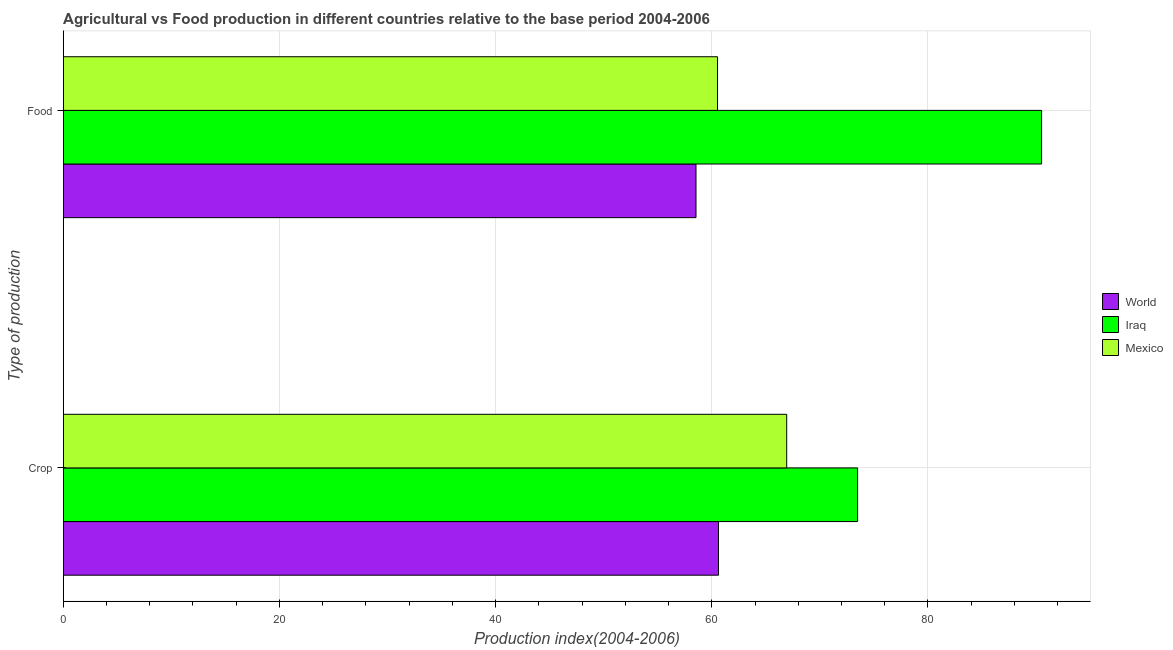How many different coloured bars are there?
Make the answer very short. 3. How many bars are there on the 2nd tick from the top?
Provide a succinct answer. 3. How many bars are there on the 2nd tick from the bottom?
Your answer should be compact. 3. What is the label of the 1st group of bars from the top?
Offer a very short reply. Food. What is the food production index in World?
Your answer should be compact. 58.54. Across all countries, what is the maximum crop production index?
Make the answer very short. 73.49. Across all countries, what is the minimum crop production index?
Ensure brevity in your answer.  60.62. In which country was the crop production index maximum?
Ensure brevity in your answer.  Iraq. In which country was the food production index minimum?
Your answer should be compact. World. What is the total food production index in the graph?
Your response must be concise. 209.58. What is the difference between the crop production index in Mexico and that in World?
Your answer should be compact. 6.31. What is the difference between the crop production index in Iraq and the food production index in World?
Your answer should be compact. 14.95. What is the average food production index per country?
Provide a short and direct response. 69.86. What is the difference between the crop production index and food production index in Mexico?
Offer a terse response. 6.4. In how many countries, is the food production index greater than 12 ?
Your answer should be compact. 3. What is the ratio of the crop production index in Mexico to that in Iraq?
Give a very brief answer. 0.91. Is the food production index in Iraq less than that in Mexico?
Your answer should be very brief. No. In how many countries, is the food production index greater than the average food production index taken over all countries?
Your answer should be compact. 1. What does the 2nd bar from the top in Food represents?
Make the answer very short. Iraq. Are all the bars in the graph horizontal?
Ensure brevity in your answer.  Yes. How many countries are there in the graph?
Your answer should be very brief. 3. What is the difference between two consecutive major ticks on the X-axis?
Ensure brevity in your answer.  20. Are the values on the major ticks of X-axis written in scientific E-notation?
Your answer should be very brief. No. Does the graph contain any zero values?
Offer a terse response. No. Does the graph contain grids?
Provide a succinct answer. Yes. Where does the legend appear in the graph?
Ensure brevity in your answer.  Center right. How many legend labels are there?
Keep it short and to the point. 3. How are the legend labels stacked?
Give a very brief answer. Vertical. What is the title of the graph?
Your answer should be very brief. Agricultural vs Food production in different countries relative to the base period 2004-2006. What is the label or title of the X-axis?
Give a very brief answer. Production index(2004-2006). What is the label or title of the Y-axis?
Offer a very short reply. Type of production. What is the Production index(2004-2006) in World in Crop?
Provide a short and direct response. 60.62. What is the Production index(2004-2006) of Iraq in Crop?
Provide a short and direct response. 73.49. What is the Production index(2004-2006) in Mexico in Crop?
Offer a very short reply. 66.93. What is the Production index(2004-2006) of World in Food?
Keep it short and to the point. 58.54. What is the Production index(2004-2006) of Iraq in Food?
Keep it short and to the point. 90.51. What is the Production index(2004-2006) of Mexico in Food?
Offer a terse response. 60.53. Across all Type of production, what is the maximum Production index(2004-2006) of World?
Keep it short and to the point. 60.62. Across all Type of production, what is the maximum Production index(2004-2006) in Iraq?
Keep it short and to the point. 90.51. Across all Type of production, what is the maximum Production index(2004-2006) of Mexico?
Offer a terse response. 66.93. Across all Type of production, what is the minimum Production index(2004-2006) in World?
Your answer should be very brief. 58.54. Across all Type of production, what is the minimum Production index(2004-2006) in Iraq?
Keep it short and to the point. 73.49. Across all Type of production, what is the minimum Production index(2004-2006) of Mexico?
Offer a terse response. 60.53. What is the total Production index(2004-2006) of World in the graph?
Your answer should be very brief. 119.16. What is the total Production index(2004-2006) in Iraq in the graph?
Offer a very short reply. 164. What is the total Production index(2004-2006) in Mexico in the graph?
Your answer should be very brief. 127.46. What is the difference between the Production index(2004-2006) of World in Crop and that in Food?
Offer a terse response. 2.08. What is the difference between the Production index(2004-2006) of Iraq in Crop and that in Food?
Make the answer very short. -17.02. What is the difference between the Production index(2004-2006) in World in Crop and the Production index(2004-2006) in Iraq in Food?
Offer a very short reply. -29.89. What is the difference between the Production index(2004-2006) in World in Crop and the Production index(2004-2006) in Mexico in Food?
Offer a terse response. 0.09. What is the difference between the Production index(2004-2006) of Iraq in Crop and the Production index(2004-2006) of Mexico in Food?
Keep it short and to the point. 12.96. What is the average Production index(2004-2006) of World per Type of production?
Provide a short and direct response. 59.58. What is the average Production index(2004-2006) of Iraq per Type of production?
Your answer should be very brief. 82. What is the average Production index(2004-2006) of Mexico per Type of production?
Ensure brevity in your answer.  63.73. What is the difference between the Production index(2004-2006) of World and Production index(2004-2006) of Iraq in Crop?
Ensure brevity in your answer.  -12.87. What is the difference between the Production index(2004-2006) in World and Production index(2004-2006) in Mexico in Crop?
Give a very brief answer. -6.31. What is the difference between the Production index(2004-2006) in Iraq and Production index(2004-2006) in Mexico in Crop?
Provide a short and direct response. 6.56. What is the difference between the Production index(2004-2006) in World and Production index(2004-2006) in Iraq in Food?
Provide a succinct answer. -31.97. What is the difference between the Production index(2004-2006) of World and Production index(2004-2006) of Mexico in Food?
Provide a succinct answer. -1.99. What is the difference between the Production index(2004-2006) in Iraq and Production index(2004-2006) in Mexico in Food?
Provide a succinct answer. 29.98. What is the ratio of the Production index(2004-2006) in World in Crop to that in Food?
Offer a terse response. 1.04. What is the ratio of the Production index(2004-2006) in Iraq in Crop to that in Food?
Provide a succinct answer. 0.81. What is the ratio of the Production index(2004-2006) in Mexico in Crop to that in Food?
Your response must be concise. 1.11. What is the difference between the highest and the second highest Production index(2004-2006) of World?
Provide a short and direct response. 2.08. What is the difference between the highest and the second highest Production index(2004-2006) in Iraq?
Your answer should be very brief. 17.02. What is the difference between the highest and the second highest Production index(2004-2006) in Mexico?
Provide a short and direct response. 6.4. What is the difference between the highest and the lowest Production index(2004-2006) of World?
Give a very brief answer. 2.08. What is the difference between the highest and the lowest Production index(2004-2006) in Iraq?
Make the answer very short. 17.02. What is the difference between the highest and the lowest Production index(2004-2006) in Mexico?
Keep it short and to the point. 6.4. 